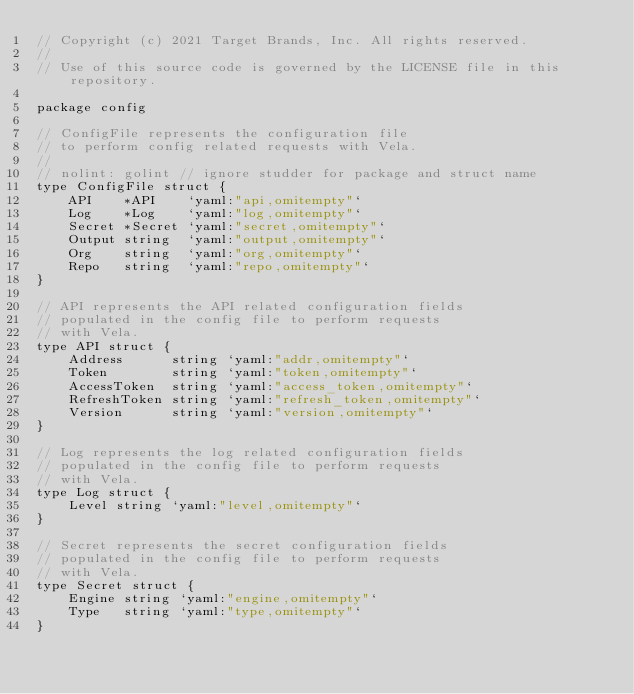Convert code to text. <code><loc_0><loc_0><loc_500><loc_500><_Go_>// Copyright (c) 2021 Target Brands, Inc. All rights reserved.
//
// Use of this source code is governed by the LICENSE file in this repository.

package config

// ConfigFile represents the configuration file
// to perform config related requests with Vela.
//
// nolint: golint // ignore studder for package and struct name
type ConfigFile struct {
	API    *API    `yaml:"api,omitempty"`
	Log    *Log    `yaml:"log,omitempty"`
	Secret *Secret `yaml:"secret,omitempty"`
	Output string  `yaml:"output,omitempty"`
	Org    string  `yaml:"org,omitempty"`
	Repo   string  `yaml:"repo,omitempty"`
}

// API represents the API related configuration fields
// populated in the config file to perform requests
// with Vela.
type API struct {
	Address      string `yaml:"addr,omitempty"`
	Token        string `yaml:"token,omitempty"`
	AccessToken  string `yaml:"access_token,omitempty"`
	RefreshToken string `yaml:"refresh_token,omitempty"`
	Version      string `yaml:"version,omitempty"`
}

// Log represents the log related configuration fields
// populated in the config file to perform requests
// with Vela.
type Log struct {
	Level string `yaml:"level,omitempty"`
}

// Secret represents the secret configuration fields
// populated in the config file to perform requests
// with Vela.
type Secret struct {
	Engine string `yaml:"engine,omitempty"`
	Type   string `yaml:"type,omitempty"`
}
</code> 